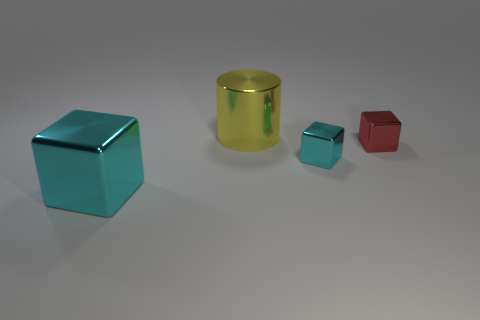What number of other things are the same color as the large cylinder?
Make the answer very short. 0. Is the material of the tiny thing left of the tiny red shiny cube the same as the big yellow thing?
Provide a short and direct response. Yes. There is a large cyan cube that is in front of the small red thing; what is its material?
Ensure brevity in your answer.  Metal. How big is the cyan shiny block on the right side of the cyan block that is to the left of the yellow cylinder?
Provide a short and direct response. Small. Is there a large cyan sphere that has the same material as the big block?
Your answer should be very brief. No. The big metallic object that is behind the small thing on the right side of the small metal block to the left of the red block is what shape?
Give a very brief answer. Cylinder. There is a big metallic object behind the big cyan object; is it the same color as the shiny thing that is left of the big yellow cylinder?
Offer a terse response. No. Is there anything else that has the same size as the red thing?
Your answer should be very brief. Yes. Are there any metal cubes to the left of the small cyan cube?
Keep it short and to the point. Yes. How many big cyan metallic things have the same shape as the red object?
Offer a very short reply. 1. 